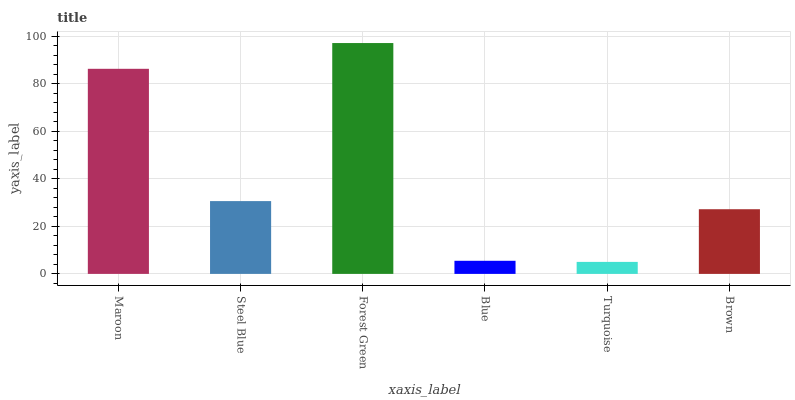Is Steel Blue the minimum?
Answer yes or no. No. Is Steel Blue the maximum?
Answer yes or no. No. Is Maroon greater than Steel Blue?
Answer yes or no. Yes. Is Steel Blue less than Maroon?
Answer yes or no. Yes. Is Steel Blue greater than Maroon?
Answer yes or no. No. Is Maroon less than Steel Blue?
Answer yes or no. No. Is Steel Blue the high median?
Answer yes or no. Yes. Is Brown the low median?
Answer yes or no. Yes. Is Turquoise the high median?
Answer yes or no. No. Is Steel Blue the low median?
Answer yes or no. No. 